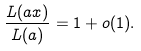Convert formula to latex. <formula><loc_0><loc_0><loc_500><loc_500>\frac { L ( a x ) } { L ( a ) } = 1 + o ( 1 ) .</formula> 